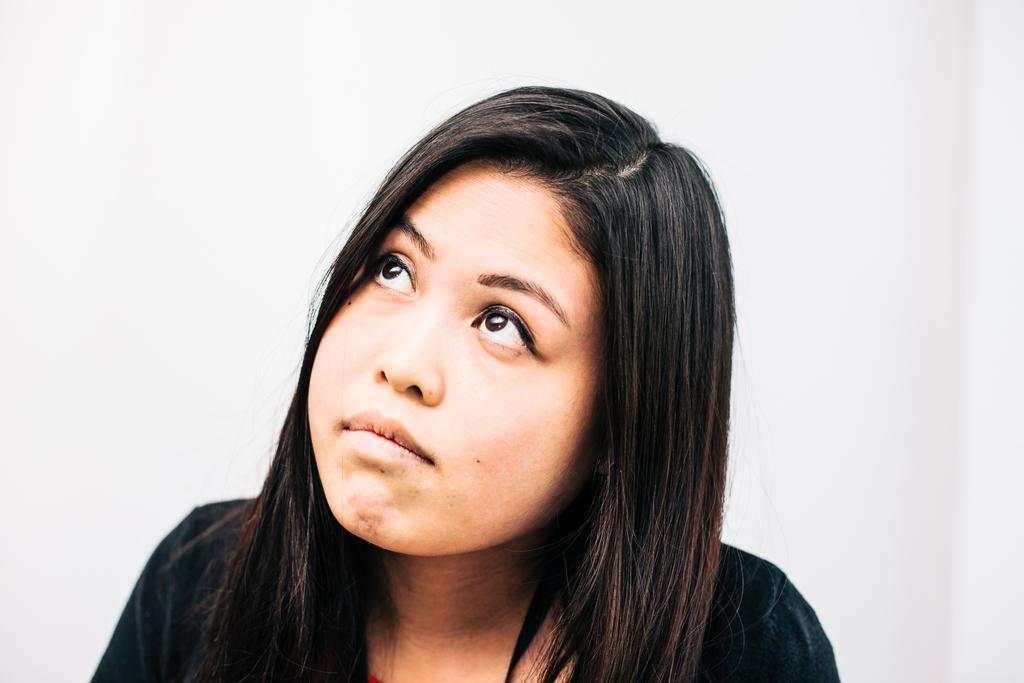Who is the main subject in the foreground of the image? There is a woman in the foreground of the image. What is the woman wearing in the image? The woman is wearing a black dress in the image. What can be seen in the background of the image? There is a white color object in the background of the image. How does the growth of the bit affect the waves in the image? There are no waves or growth of a bit present in the image. 